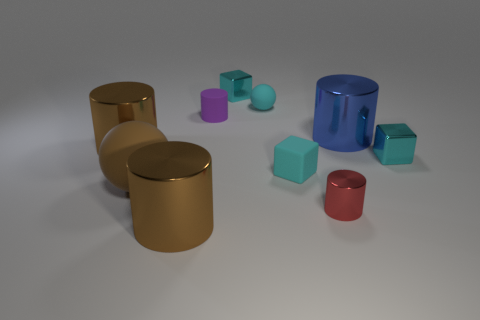Subtract all large blue cylinders. How many cylinders are left? 4 Subtract all purple cylinders. How many cylinders are left? 4 Subtract all cyan cylinders. Subtract all cyan blocks. How many cylinders are left? 5 Subtract all cubes. How many objects are left? 7 Subtract 0 purple spheres. How many objects are left? 10 Subtract all large blue shiny things. Subtract all blue shiny blocks. How many objects are left? 9 Add 3 large cylinders. How many large cylinders are left? 6 Add 3 small spheres. How many small spheres exist? 4 